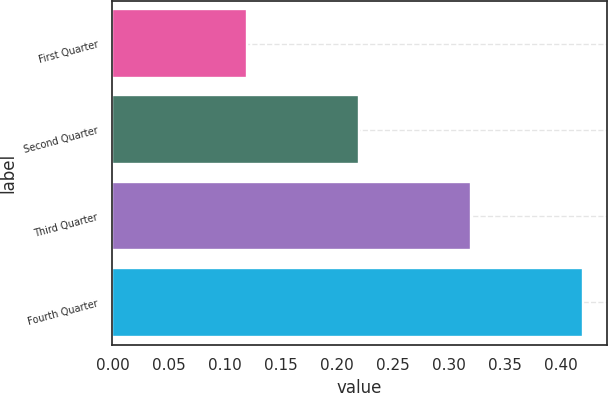<chart> <loc_0><loc_0><loc_500><loc_500><bar_chart><fcel>First Quarter<fcel>Second Quarter<fcel>Third Quarter<fcel>Fourth Quarter<nl><fcel>0.12<fcel>0.22<fcel>0.32<fcel>0.42<nl></chart> 